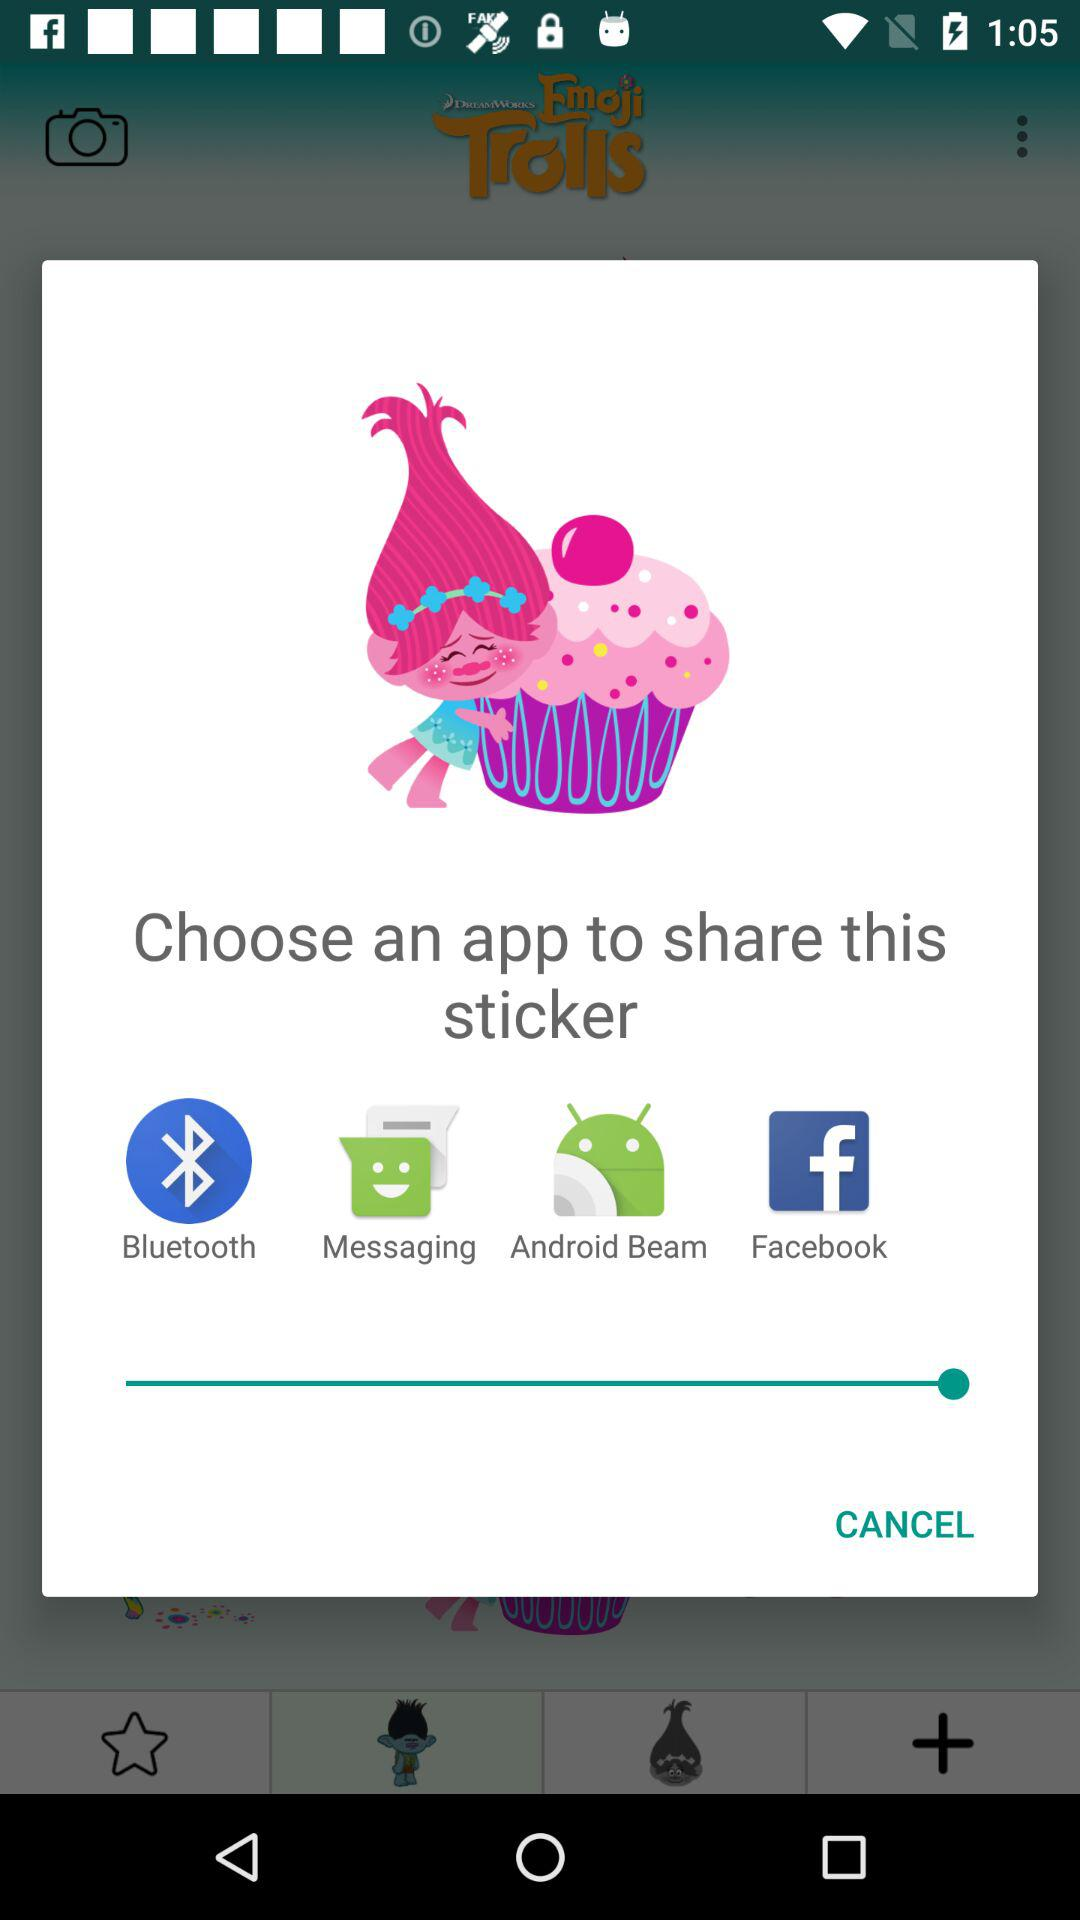What applications are available to share? The available applications to share are: "Bluetooth", "Messaging", "Android Beam", and "Facebook". 